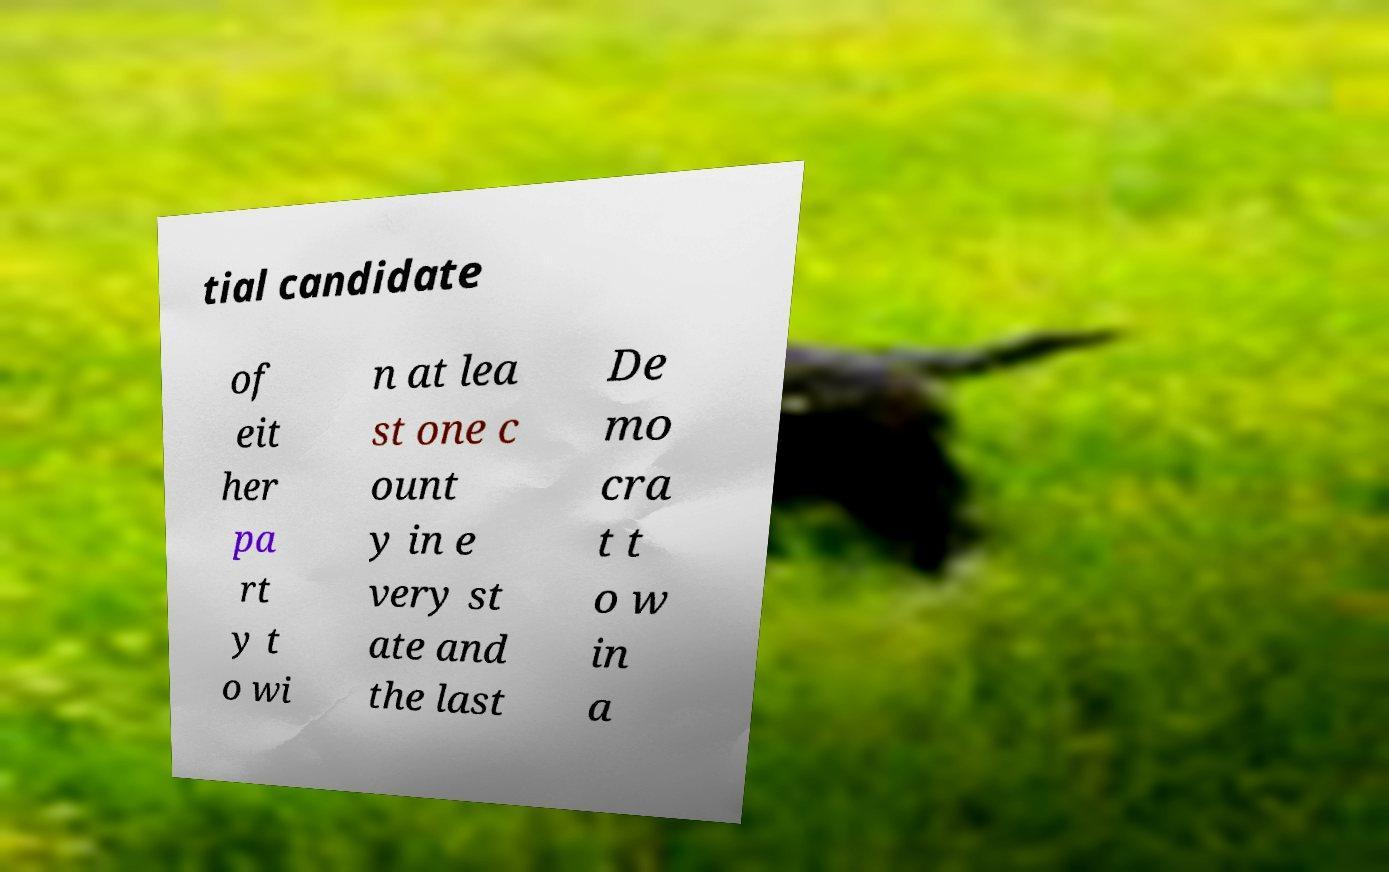Could you extract and type out the text from this image? tial candidate of eit her pa rt y t o wi n at lea st one c ount y in e very st ate and the last De mo cra t t o w in a 